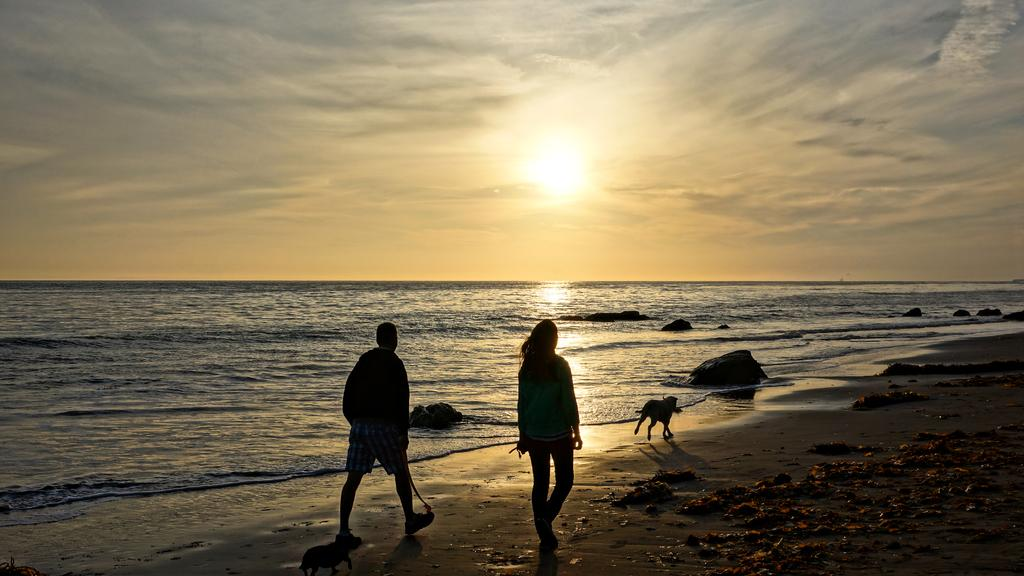How many subjects are present in the image? There are persons and a dog in the image. What are the persons and dog doing in the image? The persons and dog are walking on the sand. What can be seen in the background of the image? There is sea and sky visible in the background of the image. What is the weather like in the image? The presence of clouds and the visible sun suggest it is partly cloudy. What degree does the dog have in the image? There is no indication of a degree in the image, as it features a dog walking on the sand with the persons. How much wealth is visible in the image? There is no indication of wealth in the image; it shows a dog and persons walking on the sand near the sea. 